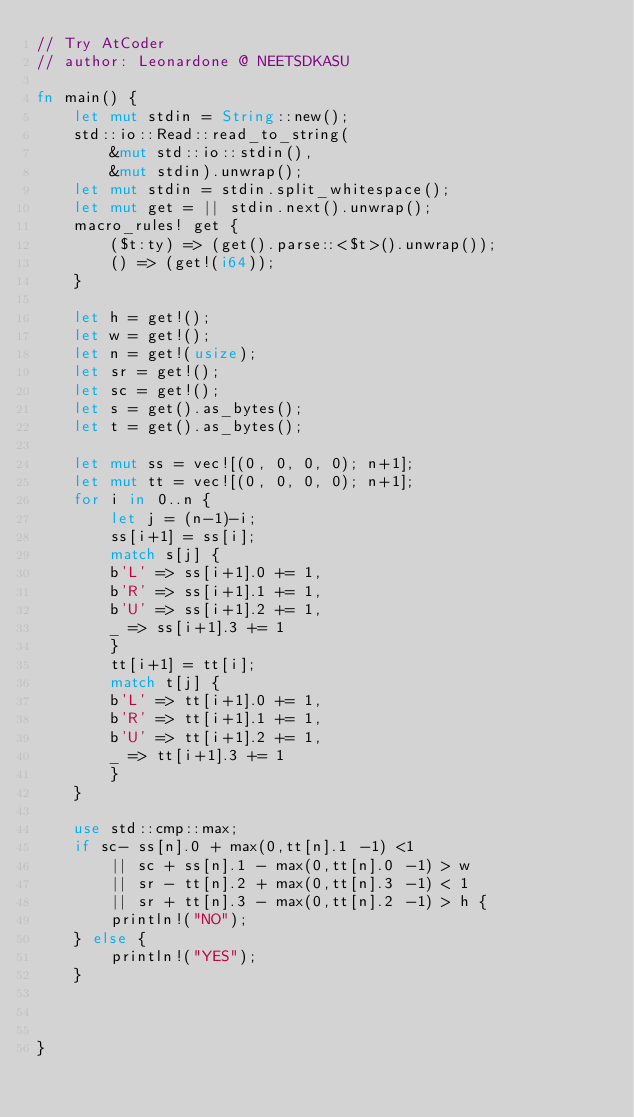Convert code to text. <code><loc_0><loc_0><loc_500><loc_500><_Rust_>// Try AtCoder
// author: Leonardone @ NEETSDKASU

fn main() {
	let mut stdin = String::new();
    std::io::Read::read_to_string(
    	&mut std::io::stdin(),
        &mut stdin).unwrap();
	let mut stdin = stdin.split_whitespace();
    let mut get = || stdin.next().unwrap();
    macro_rules! get {
    	($t:ty) => (get().parse::<$t>().unwrap());
        () => (get!(i64));
    }
    
    let h = get!();
    let w = get!();
    let n = get!(usize);
    let sr = get!();
    let sc = get!();
    let s = get().as_bytes();
    let t = get().as_bytes();
    
    let mut ss = vec![(0, 0, 0, 0); n+1];
    let mut tt = vec![(0, 0, 0, 0); n+1];
    for i in 0..n {
    	let j = (n-1)-i;
        ss[i+1] = ss[i];
        match s[j] {
        b'L' => ss[i+1].0 += 1,
        b'R' => ss[i+1].1 += 1,
        b'U' => ss[i+1].2 += 1,
        _ => ss[i+1].3 += 1
        }
        tt[i+1] = tt[i];
        match t[j] {
        b'L' => tt[i+1].0 += 1,
        b'R' => tt[i+1].1 += 1,
        b'U' => tt[i+1].2 += 1,
        _ => tt[i+1].3 += 1
        }
    }
    
    use std::cmp::max;
    if sc- ss[n].0 + max(0,tt[n].1 -1) <1
    	|| sc + ss[n].1 - max(0,tt[n].0 -1) > w
        || sr - tt[n].2 + max(0,tt[n].3 -1) < 1
        || sr + tt[n].3 - max(0,tt[n].2 -1) > h {
        println!("NO");
	} else {
    	println!("YES");
    }
    
    
    
}
</code> 